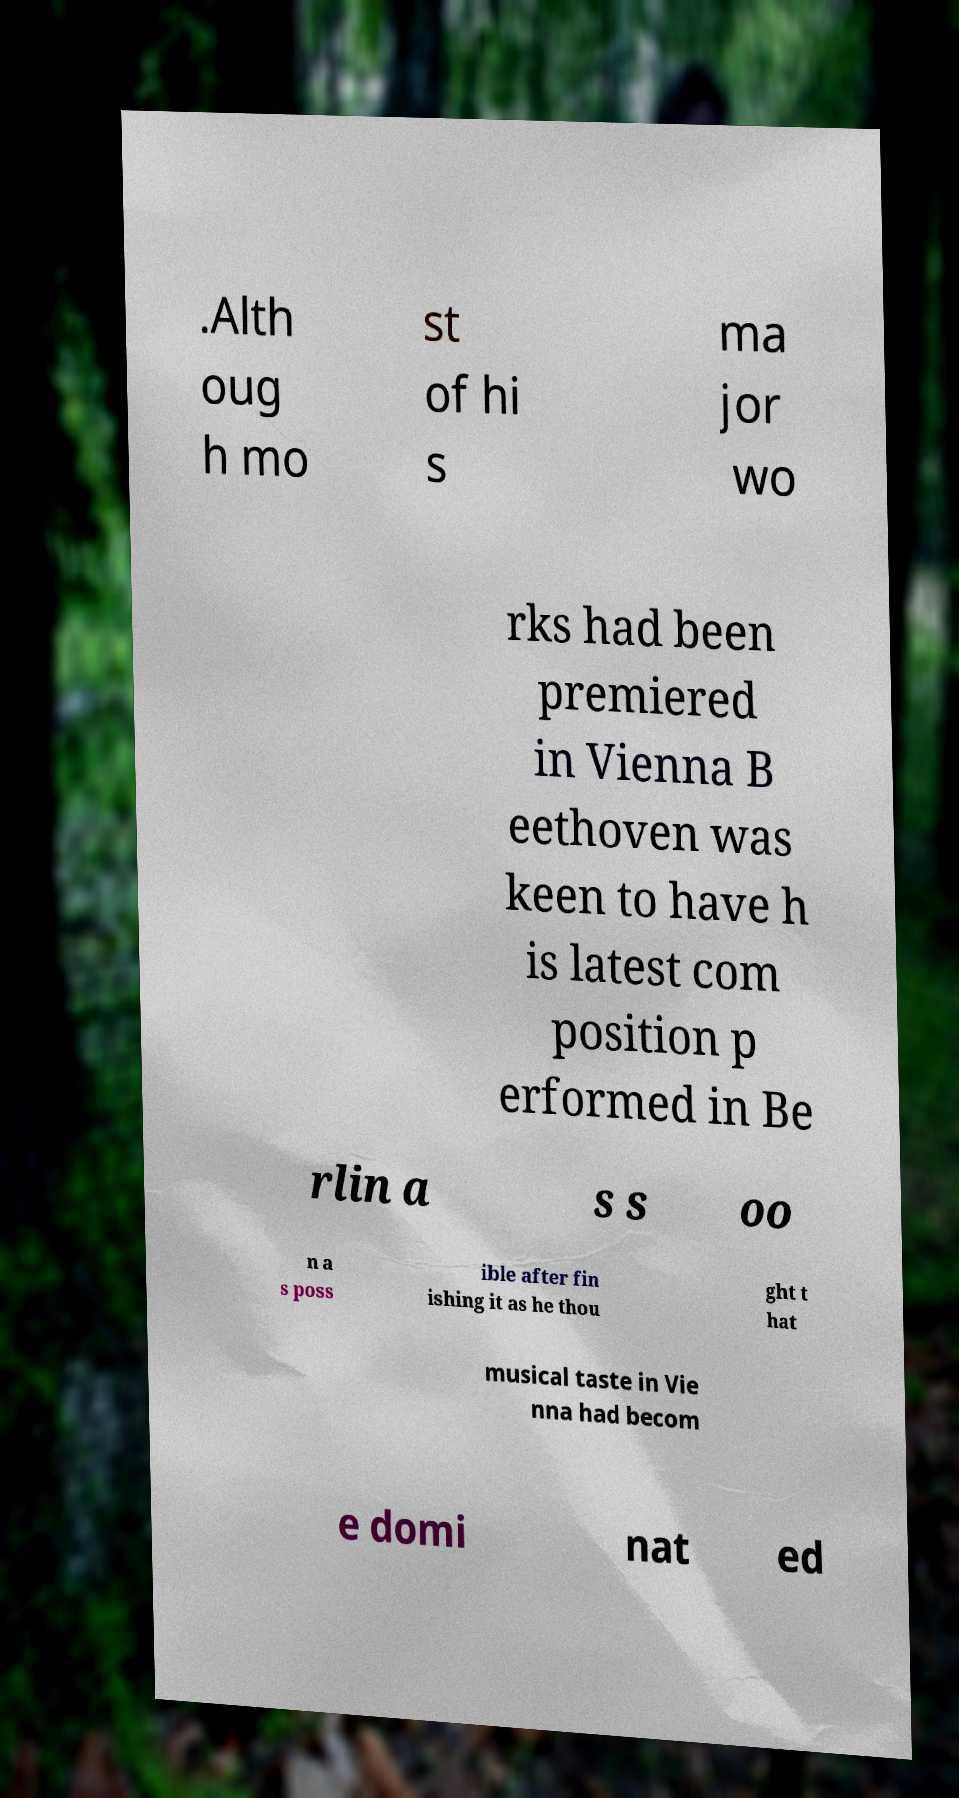What messages or text are displayed in this image? I need them in a readable, typed format. .Alth oug h mo st of hi s ma jor wo rks had been premiered in Vienna B eethoven was keen to have h is latest com position p erformed in Be rlin a s s oo n a s poss ible after fin ishing it as he thou ght t hat musical taste in Vie nna had becom e domi nat ed 